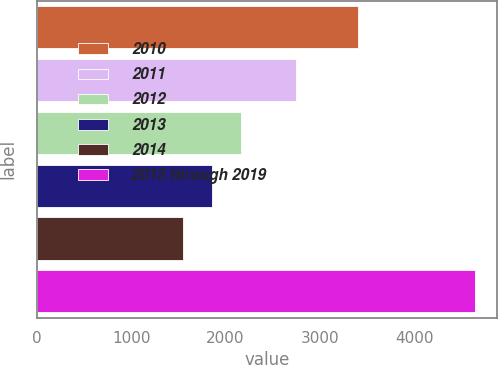<chart> <loc_0><loc_0><loc_500><loc_500><bar_chart><fcel>2010<fcel>2011<fcel>2012<fcel>2013<fcel>2014<fcel>2015 through 2019<nl><fcel>3402<fcel>2745<fcel>2168.2<fcel>1859.1<fcel>1550<fcel>4641<nl></chart> 